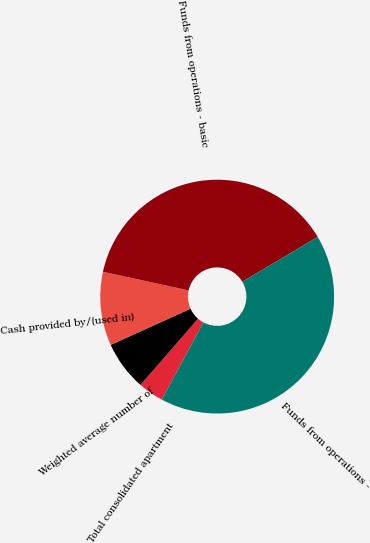<chart> <loc_0><loc_0><loc_500><loc_500><pie_chart><fcel>Total consolidated apartment<fcel>Weighted average number of<fcel>Cash provided by/(used in)<fcel>Funds from operations - basic<fcel>Funds from operations -<nl><fcel>3.53%<fcel>6.85%<fcel>10.18%<fcel>38.06%<fcel>41.38%<nl></chart> 